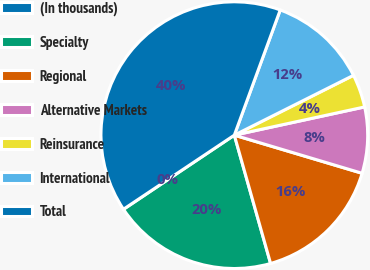Convert chart to OTSL. <chart><loc_0><loc_0><loc_500><loc_500><pie_chart><fcel>(In thousands)<fcel>Specialty<fcel>Regional<fcel>Alternative Markets<fcel>Reinsurance<fcel>International<fcel>Total<nl><fcel>0.02%<fcel>19.99%<fcel>16.0%<fcel>8.01%<fcel>4.01%<fcel>12.0%<fcel>39.97%<nl></chart> 